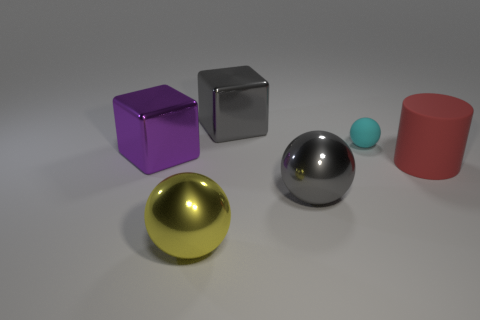What is the ball that is both left of the rubber ball and right of the big yellow object made of?
Keep it short and to the point. Metal. There is a yellow object that is to the left of the large gray cube; what material is it?
Provide a succinct answer. Metal. There is a small object that is made of the same material as the big red object; what color is it?
Give a very brief answer. Cyan. There is a purple shiny thing; is it the same shape as the large gray metallic object to the right of the gray cube?
Your answer should be compact. No. There is a big red cylinder; are there any metal objects behind it?
Ensure brevity in your answer.  Yes. There is a cyan ball; is it the same size as the gray metallic thing in front of the big purple metallic cube?
Offer a terse response. No. Is there a rubber cube of the same color as the cylinder?
Keep it short and to the point. No. Is there another large yellow object of the same shape as the yellow thing?
Your answer should be very brief. No. There is a big shiny thing that is both in front of the matte sphere and right of the big yellow metallic sphere; what is its shape?
Your answer should be very brief. Sphere. How many yellow cylinders are made of the same material as the yellow object?
Provide a short and direct response. 0. 